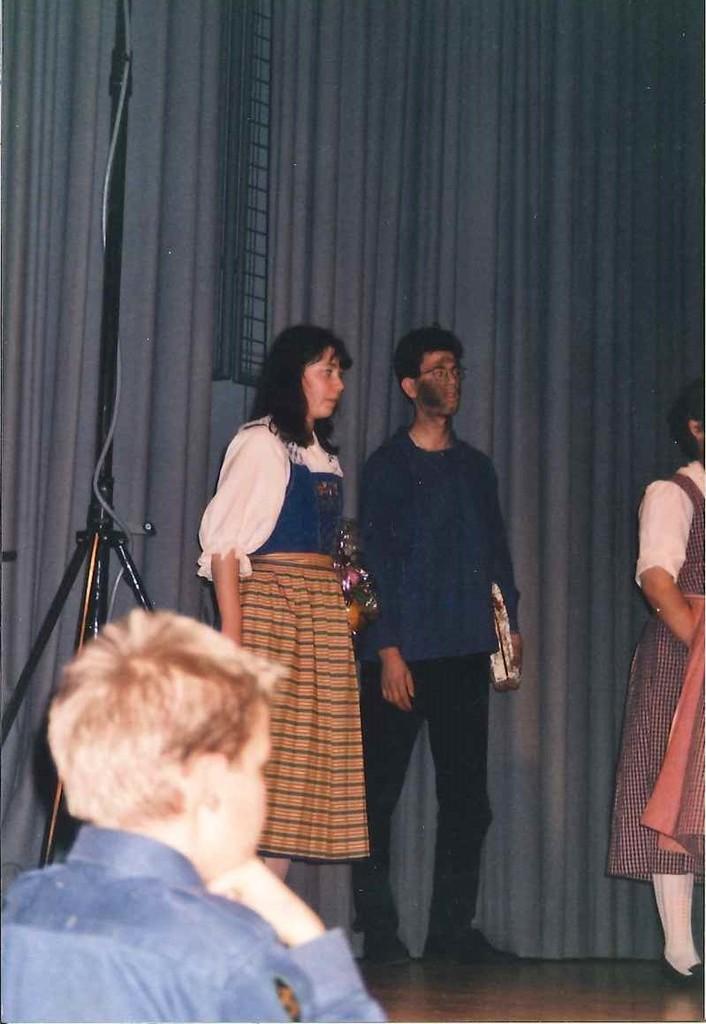Could you give a brief overview of what you see in this image? In this image we can see some group of persons standing on a stage, in the foreground of the image there is a person wearing blue color shirt and in the background of the image there is blue color curtain and there are some iron rods. 